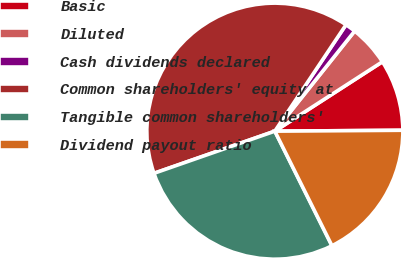Convert chart to OTSL. <chart><loc_0><loc_0><loc_500><loc_500><pie_chart><fcel>Basic<fcel>Diluted<fcel>Cash dividends declared<fcel>Common shareholders' equity at<fcel>Tangible common shareholders'<fcel>Dividend payout ratio<nl><fcel>9.01%<fcel>5.17%<fcel>1.33%<fcel>39.72%<fcel>27.02%<fcel>17.75%<nl></chart> 